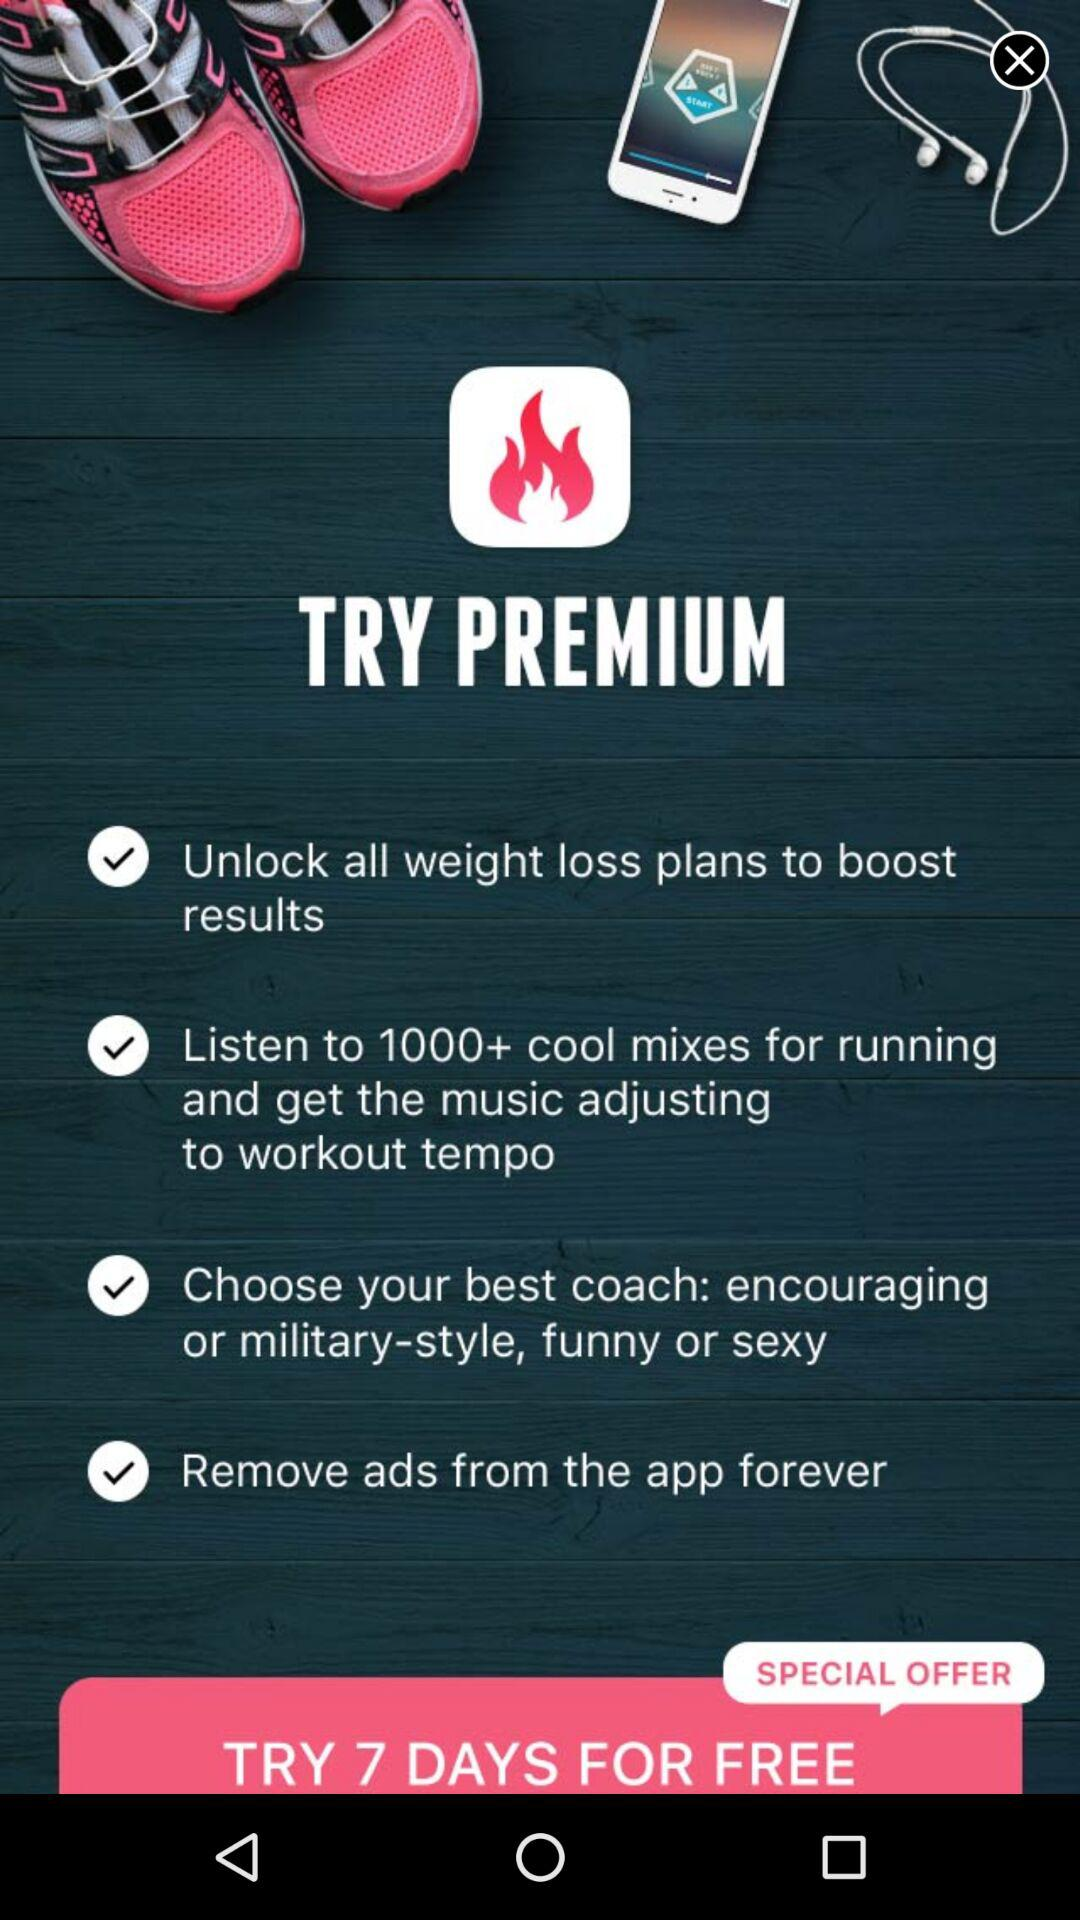How many checkbox labels are there on the screen?
Answer the question using a single word or phrase. 4 